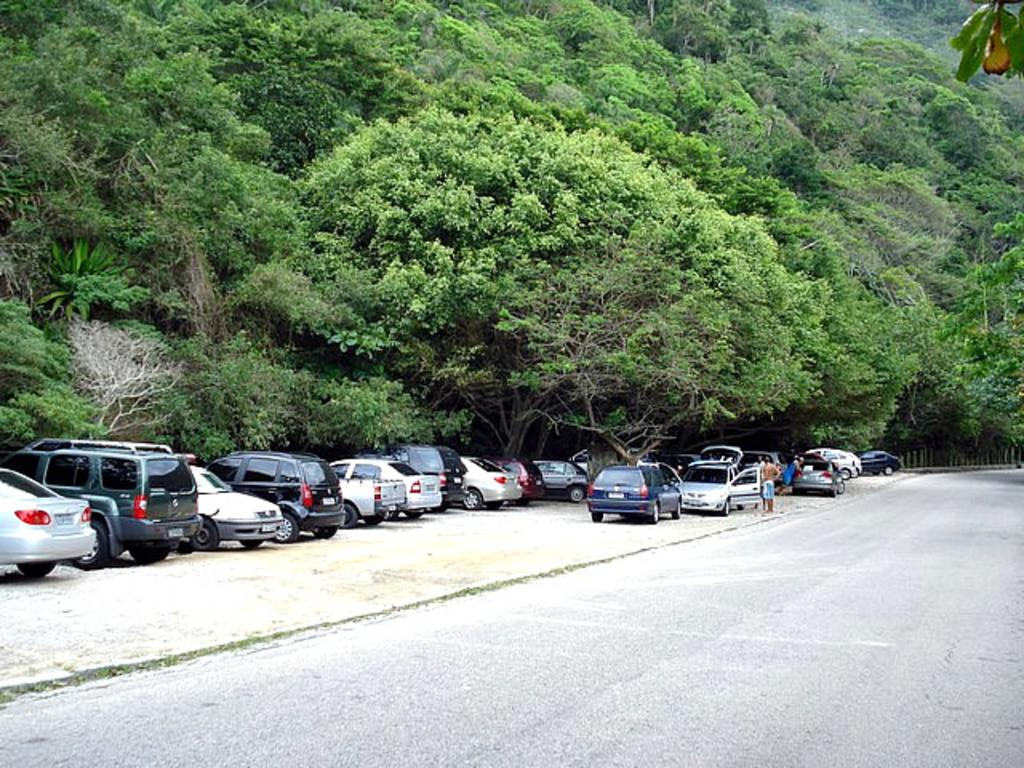Where was the image taken? The image was taken on a road. What can be seen beside the road? There is a ground beside the road. What is happening on the ground beside the road? Cars are parked on the ground. Are there any people present in the image? Yes, there are people standing near the parked cars. What can be seen in the background of the image? There are trees visible in the background. What type of thing is the person sleeping on in the image? There is no person sleeping in the image; it only shows parked cars and people standing near them. 